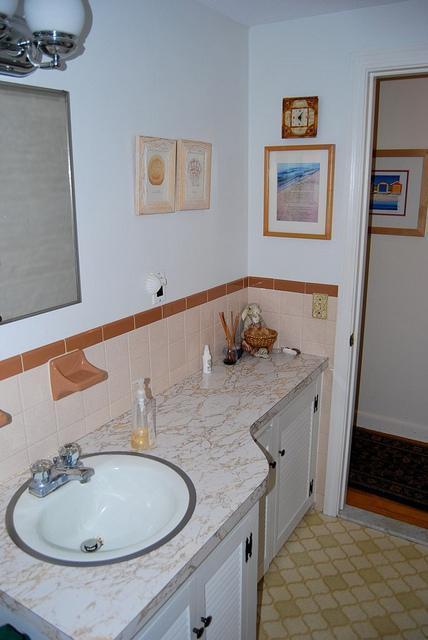How many elephant are facing the right side of the image?
Give a very brief answer. 0. 